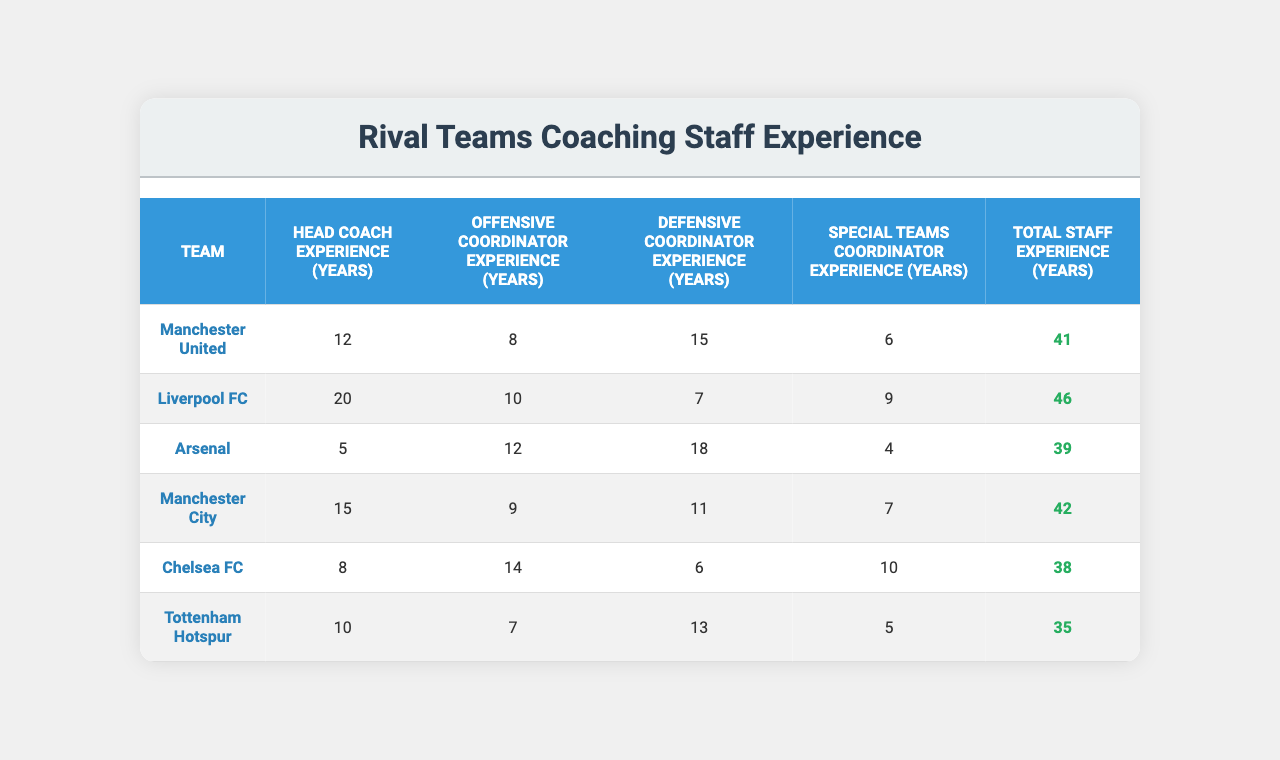What is the total staff experience for Liverpool FC? The table shows that the total staff experience for Liverpool FC is directly listed as 46 years.
Answer: 46 Which team has the least head coach experience? By comparing the "Head Coach Experience (Years)" column, Arsenal has 5 years, which is the lowest among the teams listed.
Answer: Arsenal Which team has the highest combined experience in coaching staff? The "Total Staff Experience (Years)" column indicates that Liverpool FC has the highest total at 46 years when compared to the other teams.
Answer: Liverpool FC What is the average defensive coordinator experience across all teams? To find the average, add all defensive coordinator experiences: (15 + 7 + 18 + 11 + 6 + 13) = 70. There are 6 teams, so the average is 70/6 = 11.67 years.
Answer: 11.67 Is there a team with more than 40 years of total staff experience? By looking at the "Total Staff Experience (Years)" column, both Liverpool FC and Manchester City have over 40 years, confirming the statement is true.
Answer: Yes How many teams have a head coach experience of at least 10 years? Checking the "Head Coach Experience (Years)" column reveals that Manchester United, Liverpool FC, Arsenal, Manchester City, and Tottenham Hotspur all have at least 10 years, totaling 4 teams.
Answer: 4 What is the difference in total staff experience between Chelsea FC and Tottenham Hotspur? Chelsea FC has 38 years and Tottenham Hotspur has 35 years. Calculating the difference: 38 - 35 = 3 years.
Answer: 3 Which coordinator role has the shortest average experience across all teams? To find the shortest average, calculate the average for each coordinator. The averages are: Offensive Coordinator: (8 + 10 + 12 + 9 + 14 + 7) / 6 = 10 years, Defensive Coordinator: (15 + 7 + 18 + 11 + 6 + 13) / 6 = 11.67 years, Special Teams Coordinator: (6 + 9 + 4 + 7 + 10 + 5) / 6 = 6.83 years. The Special Teams Coordinator has the shortest average experience.
Answer: Special Teams Coordinator Does Arsenal have more total staff experience than Manchester United? Arsenal has 39 years and Manchester United has 41 years. Therefore, Arsenal does not have more experience than Manchester United.
Answer: No Which team has the longest experience as an Offensive Coordinator? By checking the "Offensive Coordinator Experience (Years)" column, Chelsea FC has the longest experience at 14 years.
Answer: Chelsea FC 